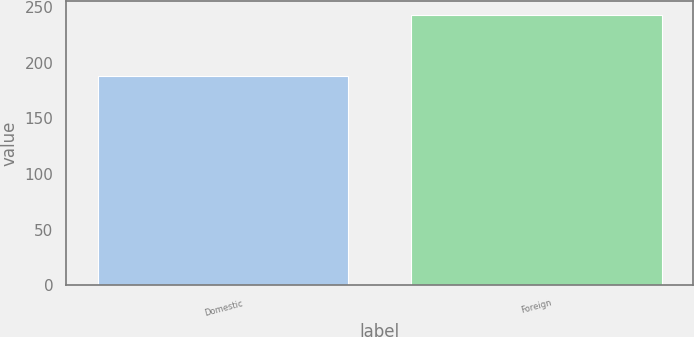Convert chart. <chart><loc_0><loc_0><loc_500><loc_500><bar_chart><fcel>Domestic<fcel>Foreign<nl><fcel>188.6<fcel>243.4<nl></chart> 